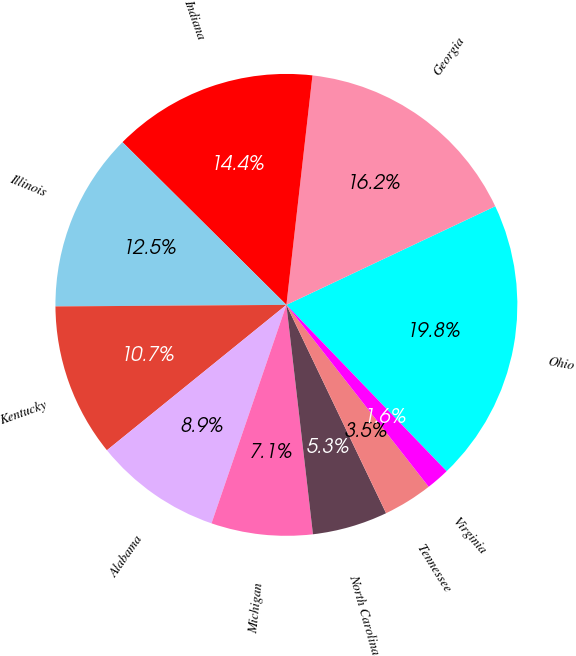<chart> <loc_0><loc_0><loc_500><loc_500><pie_chart><fcel>Ohio<fcel>Georgia<fcel>Indiana<fcel>Illinois<fcel>Kentucky<fcel>Alabama<fcel>Michigan<fcel>North Carolina<fcel>Tennessee<fcel>Virginia<nl><fcel>19.82%<fcel>16.18%<fcel>14.36%<fcel>12.55%<fcel>10.73%<fcel>8.91%<fcel>7.09%<fcel>5.27%<fcel>3.46%<fcel>1.64%<nl></chart> 